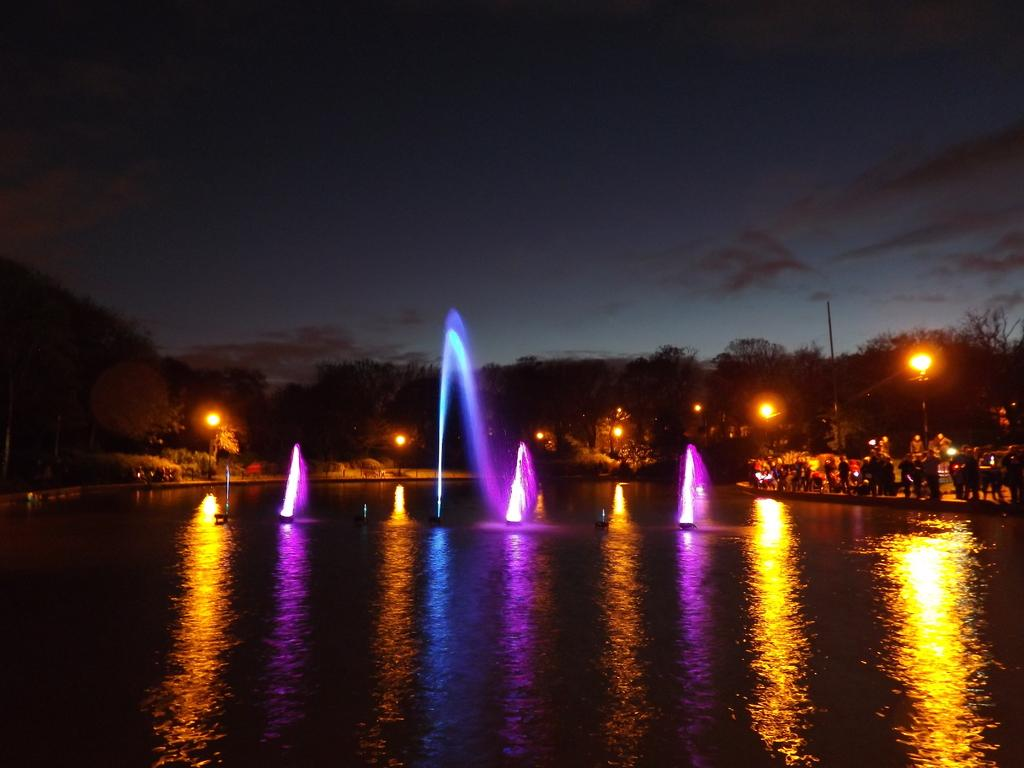What is the main element in the image? There is water in the image. What is located within the water? There is a fountain with lights in the water. What can be seen in the background of the image? There are lights, trees, poles, and the sky visible in the background. Are there any people present in the image? Yes, there are people standing on the right side of the image. Can you tell me where the gate is located in the image? There is no gate present in the image. What type of store can be seen in the background of the image? There is no store visible in the image; it features a fountain with lights in the water, surrounded by trees and poles. 